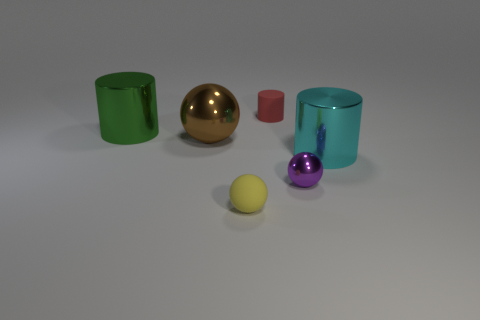Is the number of brown objects behind the big cyan metal thing less than the number of big green metallic objects?
Provide a succinct answer. No. Is the size of the cyan metal object the same as the red matte object?
Make the answer very short. No. What size is the cyan object that is made of the same material as the large green object?
Your answer should be very brief. Large. How many large metal cylinders have the same color as the large metallic ball?
Your answer should be very brief. 0. Is the number of big brown spheres in front of the purple metallic ball less than the number of cyan shiny cylinders to the left of the red rubber thing?
Keep it short and to the point. No. Is the shape of the shiny thing behind the brown object the same as  the big cyan shiny thing?
Provide a succinct answer. Yes. Are there any other things that are made of the same material as the large brown thing?
Your answer should be compact. Yes. Does the sphere that is in front of the tiny purple metallic thing have the same material as the cyan object?
Offer a very short reply. No. The ball that is behind the cylinder that is in front of the green shiny object that is behind the brown metallic thing is made of what material?
Offer a very short reply. Metal. What number of other objects are the same shape as the large green metal object?
Offer a very short reply. 2. 